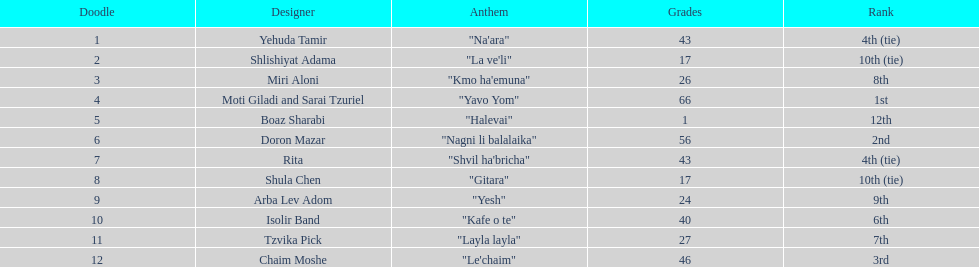Compare draws, which had the least amount of points? Boaz Sharabi. 